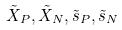Convert formula to latex. <formula><loc_0><loc_0><loc_500><loc_500>\tilde { X } _ { P } , \tilde { X } _ { N } , \tilde { s } _ { P } , \tilde { s } _ { N }</formula> 